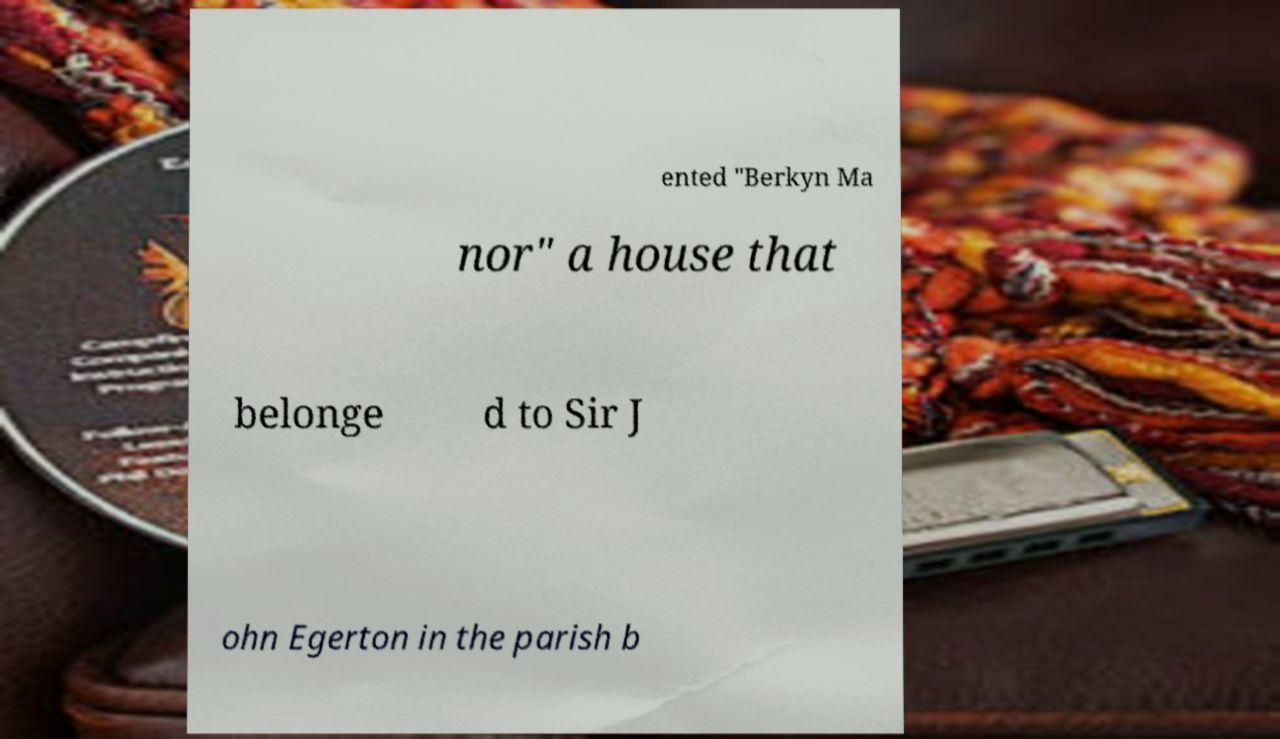Please read and relay the text visible in this image. What does it say? ented "Berkyn Ma nor" a house that belonge d to Sir J ohn Egerton in the parish b 